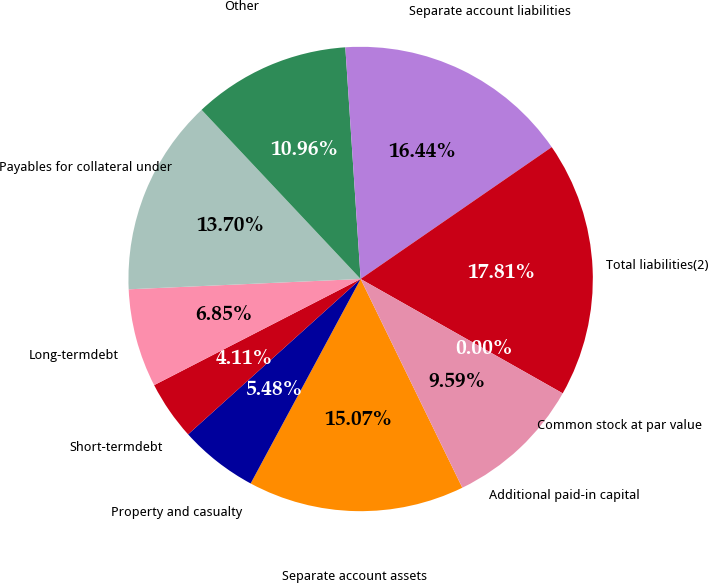Convert chart. <chart><loc_0><loc_0><loc_500><loc_500><pie_chart><fcel>Separate account assets<fcel>Property and casualty<fcel>Short-termdebt<fcel>Long-termdebt<fcel>Payables for collateral under<fcel>Other<fcel>Separate account liabilities<fcel>Total liabilities(2)<fcel>Common stock at par value<fcel>Additional paid-in capital<nl><fcel>15.07%<fcel>5.48%<fcel>4.11%<fcel>6.85%<fcel>13.7%<fcel>10.96%<fcel>16.44%<fcel>17.81%<fcel>0.0%<fcel>9.59%<nl></chart> 